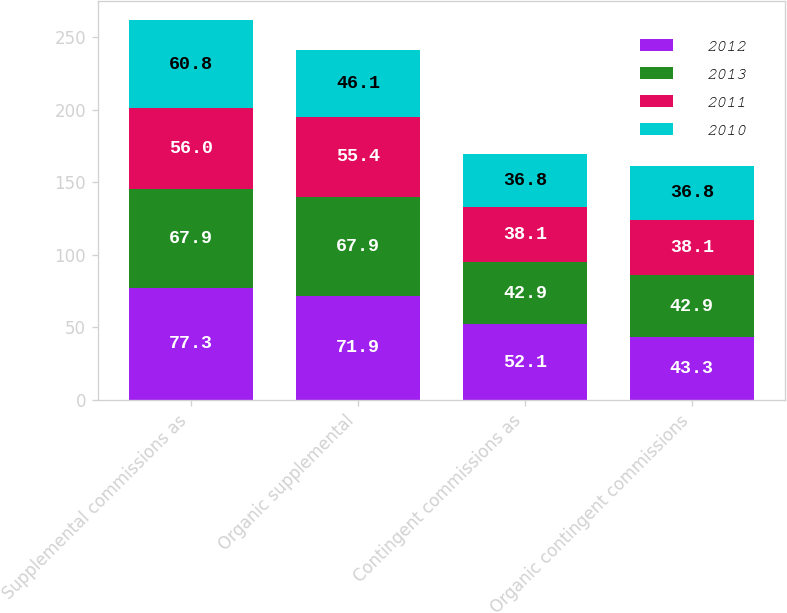Convert chart. <chart><loc_0><loc_0><loc_500><loc_500><stacked_bar_chart><ecel><fcel>Supplemental commissions as<fcel>Organic supplemental<fcel>Contingent commissions as<fcel>Organic contingent commissions<nl><fcel>2012<fcel>77.3<fcel>71.9<fcel>52.1<fcel>43.3<nl><fcel>2013<fcel>67.9<fcel>67.9<fcel>42.9<fcel>42.9<nl><fcel>2011<fcel>56<fcel>55.4<fcel>38.1<fcel>38.1<nl><fcel>2010<fcel>60.8<fcel>46.1<fcel>36.8<fcel>36.8<nl></chart> 